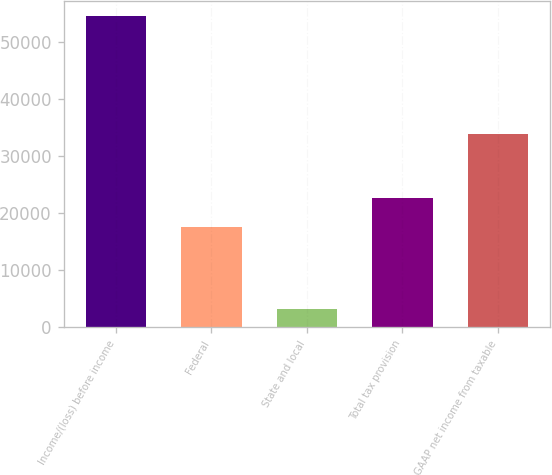Convert chart. <chart><loc_0><loc_0><loc_500><loc_500><bar_chart><fcel>Income/(loss) before income<fcel>Federal<fcel>State and local<fcel>Total tax provision<fcel>GAAP net income from taxable<nl><fcel>54522<fcel>17581<fcel>3146<fcel>22718.6<fcel>33795<nl></chart> 